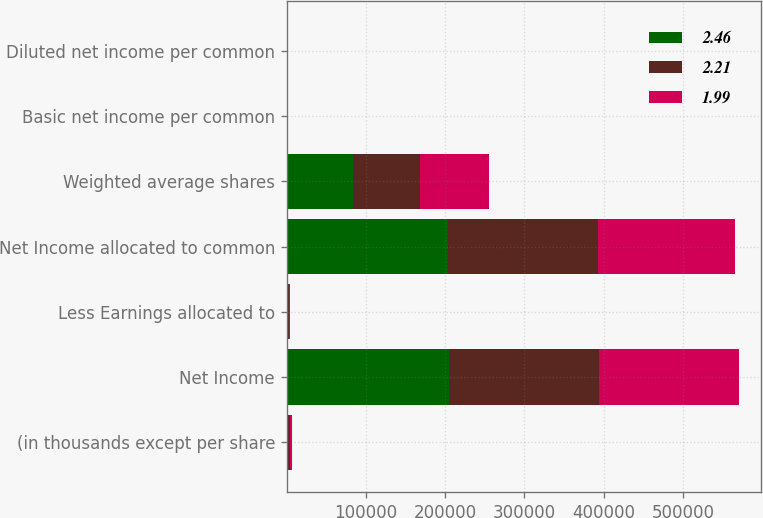Convert chart. <chart><loc_0><loc_0><loc_500><loc_500><stacked_bar_chart><ecel><fcel>(in thousands except per share<fcel>Net Income<fcel>Less Earnings allocated to<fcel>Net Income allocated to common<fcel>Weighted average shares<fcel>Basic net income per common<fcel>Diluted net income per common<nl><fcel>2.46<fcel>2015<fcel>205023<fcel>898<fcel>204125<fcel>83081<fcel>2.46<fcel>2.46<nl><fcel>2.21<fcel>2014<fcel>189714<fcel>1322<fcel>188392<fcel>85406<fcel>2.21<fcel>2.21<nl><fcel>1.99<fcel>2013<fcel>175999<fcel>2136<fcel>173863<fcel>87331<fcel>1.99<fcel>1.99<nl></chart> 